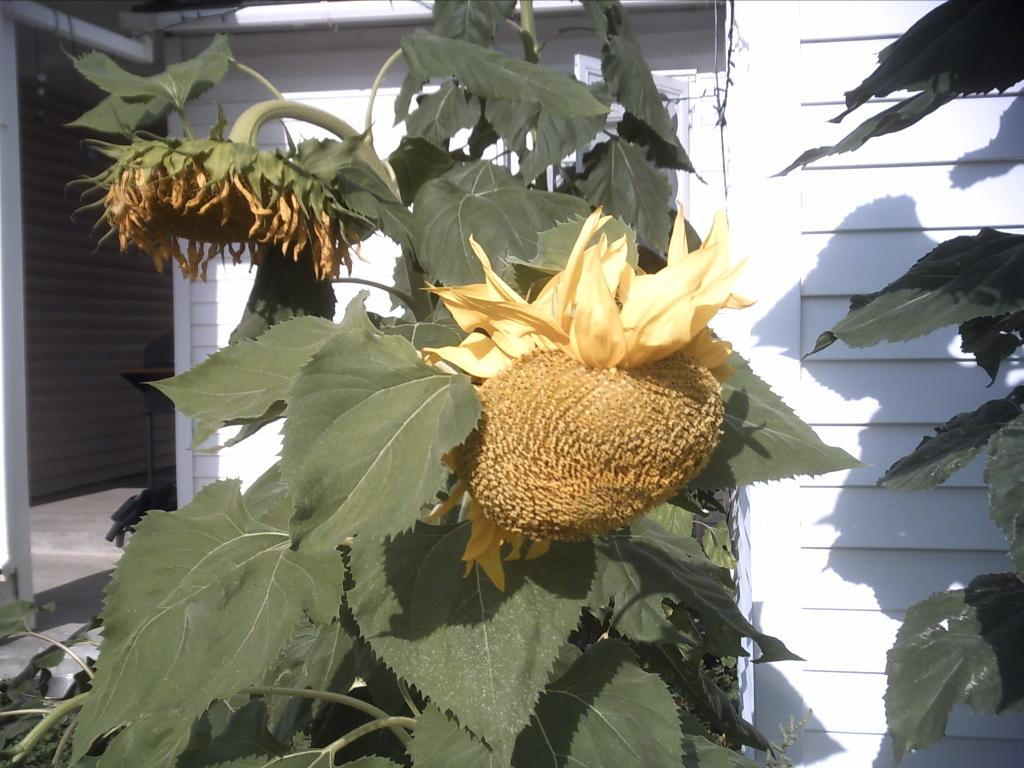What type of living organisms can be seen in the image? There are flowers and plants visible in the image. Can you describe the structure in the background of the image? There is a wooden house in the background of the image. How many legs can be seen on the cows in the image? There are no cows present in the image, so it is not possible to determine the number of legs. 